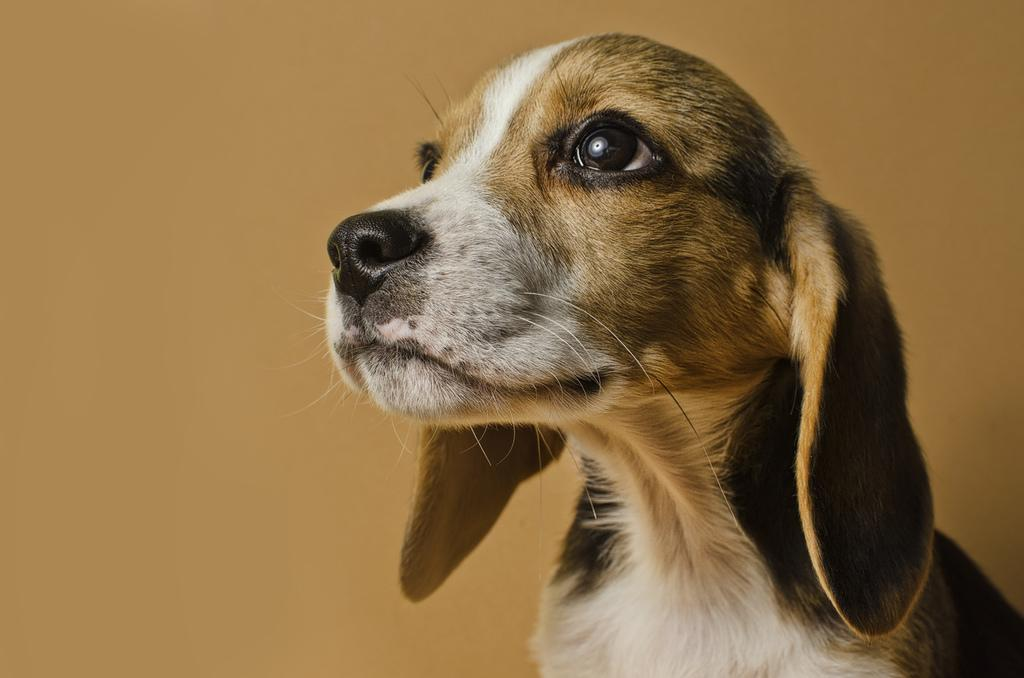What type of animal is present in the image? There is a dog in the image. What can be seen in the background of the image? There is a wall in the background of the image. What type of cakes can be seen on the wall in the image? There are no cakes present in the image; it features a dog and a wall in the background. 